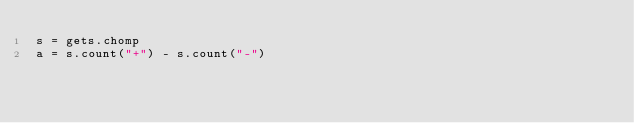Convert code to text. <code><loc_0><loc_0><loc_500><loc_500><_Ruby_>s = gets.chomp
a = s.count("+") - s.count("-")</code> 